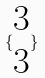<formula> <loc_0><loc_0><loc_500><loc_500>\{ \begin{matrix} 3 \\ 3 \end{matrix} \}</formula> 